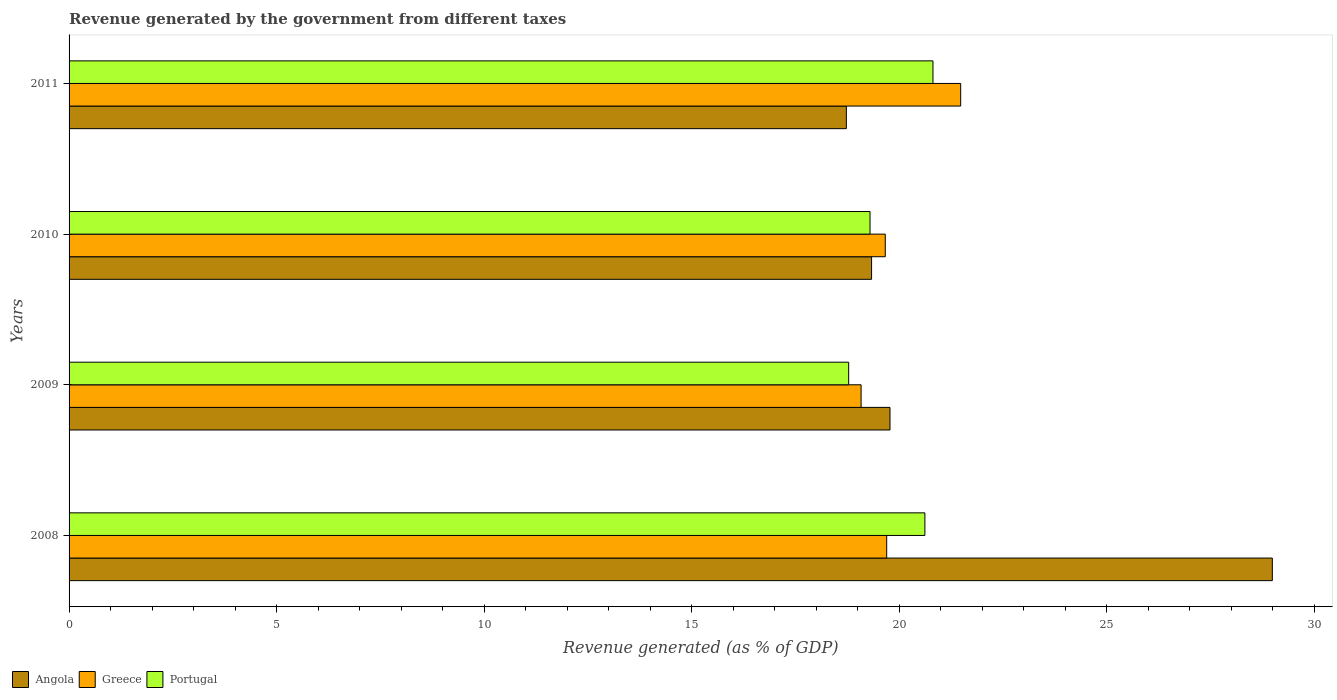How many different coloured bars are there?
Your response must be concise. 3. How many groups of bars are there?
Keep it short and to the point. 4. Are the number of bars per tick equal to the number of legend labels?
Keep it short and to the point. Yes. Are the number of bars on each tick of the Y-axis equal?
Provide a short and direct response. Yes. How many bars are there on the 2nd tick from the top?
Keep it short and to the point. 3. How many bars are there on the 2nd tick from the bottom?
Keep it short and to the point. 3. What is the label of the 3rd group of bars from the top?
Your answer should be very brief. 2009. What is the revenue generated by the government in Portugal in 2011?
Your answer should be compact. 20.81. Across all years, what is the maximum revenue generated by the government in Portugal?
Give a very brief answer. 20.81. Across all years, what is the minimum revenue generated by the government in Angola?
Your response must be concise. 18.73. What is the total revenue generated by the government in Portugal in the graph?
Your answer should be very brief. 79.51. What is the difference between the revenue generated by the government in Angola in 2008 and that in 2011?
Your answer should be compact. 10.26. What is the difference between the revenue generated by the government in Portugal in 2011 and the revenue generated by the government in Angola in 2008?
Your response must be concise. -8.18. What is the average revenue generated by the government in Portugal per year?
Make the answer very short. 19.88. In the year 2008, what is the difference between the revenue generated by the government in Greece and revenue generated by the government in Portugal?
Provide a short and direct response. -0.92. What is the ratio of the revenue generated by the government in Portugal in 2008 to that in 2009?
Keep it short and to the point. 1.1. Is the difference between the revenue generated by the government in Greece in 2008 and 2009 greater than the difference between the revenue generated by the government in Portugal in 2008 and 2009?
Make the answer very short. No. What is the difference between the highest and the second highest revenue generated by the government in Greece?
Your answer should be compact. 1.78. What is the difference between the highest and the lowest revenue generated by the government in Angola?
Your response must be concise. 10.26. Is the sum of the revenue generated by the government in Greece in 2008 and 2010 greater than the maximum revenue generated by the government in Angola across all years?
Offer a very short reply. Yes. What does the 1st bar from the bottom in 2010 represents?
Your response must be concise. Angola. How many bars are there?
Your answer should be compact. 12. How many years are there in the graph?
Provide a short and direct response. 4. Are the values on the major ticks of X-axis written in scientific E-notation?
Offer a terse response. No. Does the graph contain grids?
Keep it short and to the point. No. How many legend labels are there?
Offer a very short reply. 3. What is the title of the graph?
Provide a short and direct response. Revenue generated by the government from different taxes. Does "Faeroe Islands" appear as one of the legend labels in the graph?
Provide a short and direct response. No. What is the label or title of the X-axis?
Provide a short and direct response. Revenue generated (as % of GDP). What is the Revenue generated (as % of GDP) of Angola in 2008?
Provide a short and direct response. 28.99. What is the Revenue generated (as % of GDP) of Greece in 2008?
Offer a very short reply. 19.7. What is the Revenue generated (as % of GDP) in Portugal in 2008?
Your answer should be compact. 20.62. What is the Revenue generated (as % of GDP) of Angola in 2009?
Offer a terse response. 19.78. What is the Revenue generated (as % of GDP) in Greece in 2009?
Keep it short and to the point. 19.08. What is the Revenue generated (as % of GDP) in Portugal in 2009?
Give a very brief answer. 18.78. What is the Revenue generated (as % of GDP) in Angola in 2010?
Your answer should be very brief. 19.33. What is the Revenue generated (as % of GDP) of Greece in 2010?
Make the answer very short. 19.66. What is the Revenue generated (as % of GDP) of Portugal in 2010?
Your answer should be compact. 19.3. What is the Revenue generated (as % of GDP) of Angola in 2011?
Keep it short and to the point. 18.73. What is the Revenue generated (as % of GDP) in Greece in 2011?
Keep it short and to the point. 21.48. What is the Revenue generated (as % of GDP) of Portugal in 2011?
Your answer should be very brief. 20.81. Across all years, what is the maximum Revenue generated (as % of GDP) in Angola?
Provide a succinct answer. 28.99. Across all years, what is the maximum Revenue generated (as % of GDP) in Greece?
Your answer should be compact. 21.48. Across all years, what is the maximum Revenue generated (as % of GDP) in Portugal?
Your response must be concise. 20.81. Across all years, what is the minimum Revenue generated (as % of GDP) of Angola?
Give a very brief answer. 18.73. Across all years, what is the minimum Revenue generated (as % of GDP) in Greece?
Provide a succinct answer. 19.08. Across all years, what is the minimum Revenue generated (as % of GDP) in Portugal?
Your answer should be very brief. 18.78. What is the total Revenue generated (as % of GDP) in Angola in the graph?
Ensure brevity in your answer.  86.83. What is the total Revenue generated (as % of GDP) in Greece in the graph?
Your answer should be very brief. 79.92. What is the total Revenue generated (as % of GDP) of Portugal in the graph?
Give a very brief answer. 79.51. What is the difference between the Revenue generated (as % of GDP) of Angola in 2008 and that in 2009?
Your answer should be very brief. 9.21. What is the difference between the Revenue generated (as % of GDP) of Greece in 2008 and that in 2009?
Make the answer very short. 0.62. What is the difference between the Revenue generated (as % of GDP) in Portugal in 2008 and that in 2009?
Provide a succinct answer. 1.84. What is the difference between the Revenue generated (as % of GDP) of Angola in 2008 and that in 2010?
Your response must be concise. 9.65. What is the difference between the Revenue generated (as % of GDP) of Greece in 2008 and that in 2010?
Your answer should be very brief. 0.03. What is the difference between the Revenue generated (as % of GDP) of Portugal in 2008 and that in 2010?
Your answer should be compact. 1.32. What is the difference between the Revenue generated (as % of GDP) in Angola in 2008 and that in 2011?
Provide a short and direct response. 10.26. What is the difference between the Revenue generated (as % of GDP) of Greece in 2008 and that in 2011?
Provide a succinct answer. -1.78. What is the difference between the Revenue generated (as % of GDP) of Portugal in 2008 and that in 2011?
Offer a very short reply. -0.19. What is the difference between the Revenue generated (as % of GDP) in Angola in 2009 and that in 2010?
Keep it short and to the point. 0.44. What is the difference between the Revenue generated (as % of GDP) in Greece in 2009 and that in 2010?
Your answer should be compact. -0.58. What is the difference between the Revenue generated (as % of GDP) in Portugal in 2009 and that in 2010?
Make the answer very short. -0.51. What is the difference between the Revenue generated (as % of GDP) of Angola in 2009 and that in 2011?
Your answer should be compact. 1.05. What is the difference between the Revenue generated (as % of GDP) in Greece in 2009 and that in 2011?
Offer a terse response. -2.4. What is the difference between the Revenue generated (as % of GDP) in Portugal in 2009 and that in 2011?
Your answer should be very brief. -2.03. What is the difference between the Revenue generated (as % of GDP) in Angola in 2010 and that in 2011?
Keep it short and to the point. 0.61. What is the difference between the Revenue generated (as % of GDP) in Greece in 2010 and that in 2011?
Give a very brief answer. -1.82. What is the difference between the Revenue generated (as % of GDP) of Portugal in 2010 and that in 2011?
Offer a terse response. -1.52. What is the difference between the Revenue generated (as % of GDP) of Angola in 2008 and the Revenue generated (as % of GDP) of Greece in 2009?
Make the answer very short. 9.91. What is the difference between the Revenue generated (as % of GDP) in Angola in 2008 and the Revenue generated (as % of GDP) in Portugal in 2009?
Provide a succinct answer. 10.21. What is the difference between the Revenue generated (as % of GDP) in Greece in 2008 and the Revenue generated (as % of GDP) in Portugal in 2009?
Your answer should be very brief. 0.92. What is the difference between the Revenue generated (as % of GDP) in Angola in 2008 and the Revenue generated (as % of GDP) in Greece in 2010?
Offer a very short reply. 9.32. What is the difference between the Revenue generated (as % of GDP) in Angola in 2008 and the Revenue generated (as % of GDP) in Portugal in 2010?
Offer a terse response. 9.69. What is the difference between the Revenue generated (as % of GDP) in Greece in 2008 and the Revenue generated (as % of GDP) in Portugal in 2010?
Ensure brevity in your answer.  0.4. What is the difference between the Revenue generated (as % of GDP) in Angola in 2008 and the Revenue generated (as % of GDP) in Greece in 2011?
Make the answer very short. 7.51. What is the difference between the Revenue generated (as % of GDP) in Angola in 2008 and the Revenue generated (as % of GDP) in Portugal in 2011?
Keep it short and to the point. 8.18. What is the difference between the Revenue generated (as % of GDP) of Greece in 2008 and the Revenue generated (as % of GDP) of Portugal in 2011?
Give a very brief answer. -1.11. What is the difference between the Revenue generated (as % of GDP) of Angola in 2009 and the Revenue generated (as % of GDP) of Greece in 2010?
Offer a terse response. 0.11. What is the difference between the Revenue generated (as % of GDP) in Angola in 2009 and the Revenue generated (as % of GDP) in Portugal in 2010?
Provide a short and direct response. 0.48. What is the difference between the Revenue generated (as % of GDP) in Greece in 2009 and the Revenue generated (as % of GDP) in Portugal in 2010?
Provide a short and direct response. -0.22. What is the difference between the Revenue generated (as % of GDP) of Angola in 2009 and the Revenue generated (as % of GDP) of Greece in 2011?
Your response must be concise. -1.7. What is the difference between the Revenue generated (as % of GDP) of Angola in 2009 and the Revenue generated (as % of GDP) of Portugal in 2011?
Your answer should be compact. -1.04. What is the difference between the Revenue generated (as % of GDP) of Greece in 2009 and the Revenue generated (as % of GDP) of Portugal in 2011?
Your answer should be very brief. -1.73. What is the difference between the Revenue generated (as % of GDP) in Angola in 2010 and the Revenue generated (as % of GDP) in Greece in 2011?
Provide a succinct answer. -2.15. What is the difference between the Revenue generated (as % of GDP) in Angola in 2010 and the Revenue generated (as % of GDP) in Portugal in 2011?
Keep it short and to the point. -1.48. What is the difference between the Revenue generated (as % of GDP) of Greece in 2010 and the Revenue generated (as % of GDP) of Portugal in 2011?
Offer a very short reply. -1.15. What is the average Revenue generated (as % of GDP) of Angola per year?
Your answer should be compact. 21.71. What is the average Revenue generated (as % of GDP) of Greece per year?
Keep it short and to the point. 19.98. What is the average Revenue generated (as % of GDP) of Portugal per year?
Make the answer very short. 19.88. In the year 2008, what is the difference between the Revenue generated (as % of GDP) in Angola and Revenue generated (as % of GDP) in Greece?
Give a very brief answer. 9.29. In the year 2008, what is the difference between the Revenue generated (as % of GDP) of Angola and Revenue generated (as % of GDP) of Portugal?
Give a very brief answer. 8.37. In the year 2008, what is the difference between the Revenue generated (as % of GDP) in Greece and Revenue generated (as % of GDP) in Portugal?
Offer a very short reply. -0.92. In the year 2009, what is the difference between the Revenue generated (as % of GDP) of Angola and Revenue generated (as % of GDP) of Greece?
Provide a succinct answer. 0.7. In the year 2009, what is the difference between the Revenue generated (as % of GDP) in Greece and Revenue generated (as % of GDP) in Portugal?
Make the answer very short. 0.3. In the year 2010, what is the difference between the Revenue generated (as % of GDP) in Angola and Revenue generated (as % of GDP) in Greece?
Provide a short and direct response. -0.33. In the year 2010, what is the difference between the Revenue generated (as % of GDP) of Angola and Revenue generated (as % of GDP) of Portugal?
Offer a terse response. 0.04. In the year 2010, what is the difference between the Revenue generated (as % of GDP) of Greece and Revenue generated (as % of GDP) of Portugal?
Make the answer very short. 0.37. In the year 2011, what is the difference between the Revenue generated (as % of GDP) in Angola and Revenue generated (as % of GDP) in Greece?
Make the answer very short. -2.75. In the year 2011, what is the difference between the Revenue generated (as % of GDP) of Angola and Revenue generated (as % of GDP) of Portugal?
Your response must be concise. -2.09. In the year 2011, what is the difference between the Revenue generated (as % of GDP) in Greece and Revenue generated (as % of GDP) in Portugal?
Provide a succinct answer. 0.67. What is the ratio of the Revenue generated (as % of GDP) of Angola in 2008 to that in 2009?
Give a very brief answer. 1.47. What is the ratio of the Revenue generated (as % of GDP) in Greece in 2008 to that in 2009?
Ensure brevity in your answer.  1.03. What is the ratio of the Revenue generated (as % of GDP) in Portugal in 2008 to that in 2009?
Make the answer very short. 1.1. What is the ratio of the Revenue generated (as % of GDP) of Angola in 2008 to that in 2010?
Offer a terse response. 1.5. What is the ratio of the Revenue generated (as % of GDP) of Greece in 2008 to that in 2010?
Make the answer very short. 1. What is the ratio of the Revenue generated (as % of GDP) in Portugal in 2008 to that in 2010?
Ensure brevity in your answer.  1.07. What is the ratio of the Revenue generated (as % of GDP) in Angola in 2008 to that in 2011?
Provide a short and direct response. 1.55. What is the ratio of the Revenue generated (as % of GDP) of Greece in 2008 to that in 2011?
Give a very brief answer. 0.92. What is the ratio of the Revenue generated (as % of GDP) of Greece in 2009 to that in 2010?
Make the answer very short. 0.97. What is the ratio of the Revenue generated (as % of GDP) of Portugal in 2009 to that in 2010?
Provide a succinct answer. 0.97. What is the ratio of the Revenue generated (as % of GDP) in Angola in 2009 to that in 2011?
Offer a very short reply. 1.06. What is the ratio of the Revenue generated (as % of GDP) in Greece in 2009 to that in 2011?
Provide a short and direct response. 0.89. What is the ratio of the Revenue generated (as % of GDP) in Portugal in 2009 to that in 2011?
Give a very brief answer. 0.9. What is the ratio of the Revenue generated (as % of GDP) in Angola in 2010 to that in 2011?
Offer a very short reply. 1.03. What is the ratio of the Revenue generated (as % of GDP) of Greece in 2010 to that in 2011?
Offer a very short reply. 0.92. What is the ratio of the Revenue generated (as % of GDP) of Portugal in 2010 to that in 2011?
Offer a very short reply. 0.93. What is the difference between the highest and the second highest Revenue generated (as % of GDP) in Angola?
Your answer should be compact. 9.21. What is the difference between the highest and the second highest Revenue generated (as % of GDP) of Greece?
Provide a succinct answer. 1.78. What is the difference between the highest and the second highest Revenue generated (as % of GDP) of Portugal?
Keep it short and to the point. 0.19. What is the difference between the highest and the lowest Revenue generated (as % of GDP) in Angola?
Give a very brief answer. 10.26. What is the difference between the highest and the lowest Revenue generated (as % of GDP) of Greece?
Offer a very short reply. 2.4. What is the difference between the highest and the lowest Revenue generated (as % of GDP) of Portugal?
Your response must be concise. 2.03. 